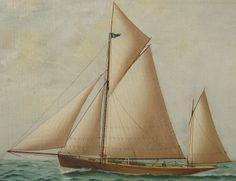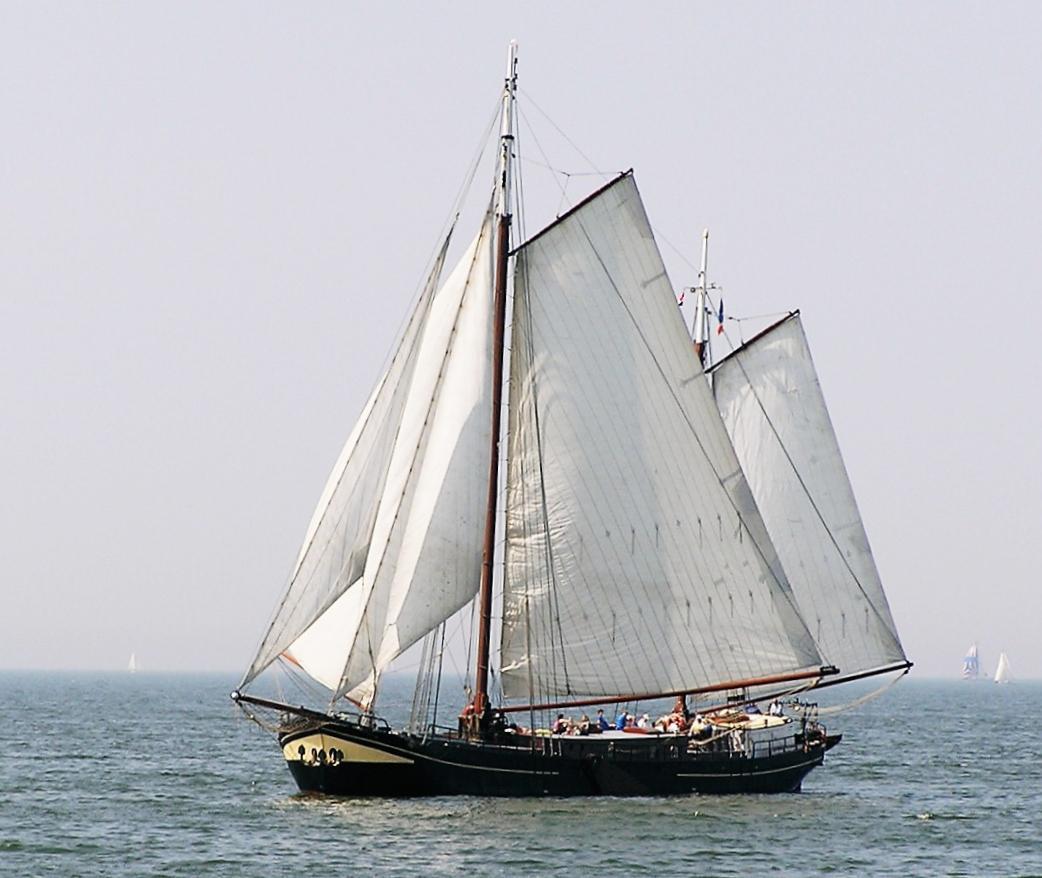The first image is the image on the left, the second image is the image on the right. Given the left and right images, does the statement "A few clouds are visible in the picture on the left." hold true? Answer yes or no. Yes. The first image is the image on the left, the second image is the image on the right. Assess this claim about the two images: "An image shows a boat with white sails in a body of blue water.". Correct or not? Answer yes or no. Yes. 